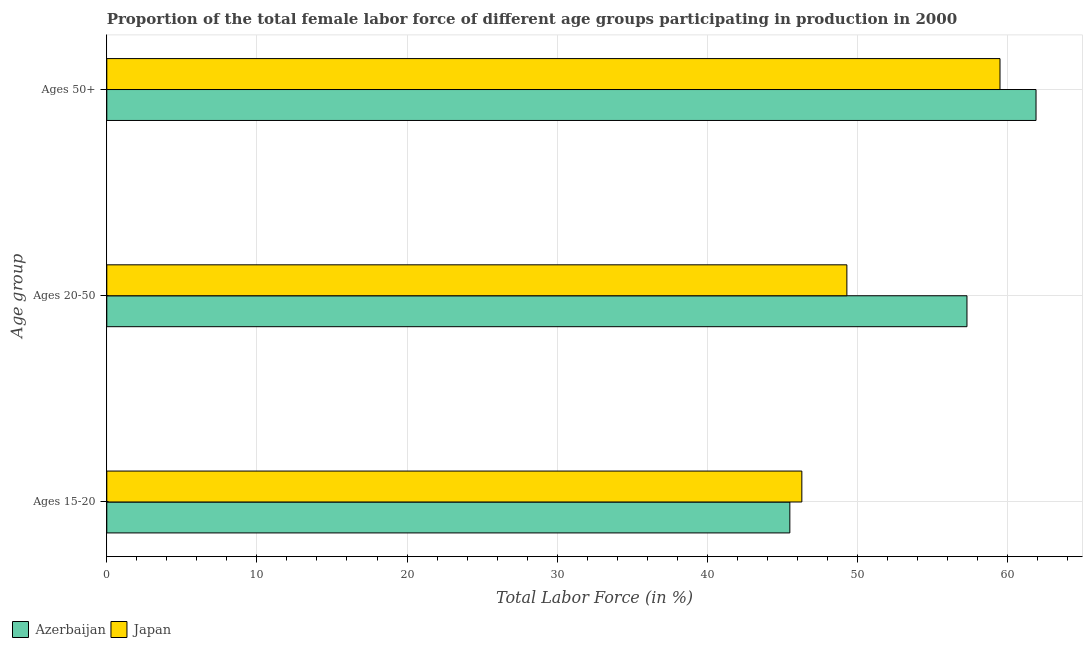Are the number of bars per tick equal to the number of legend labels?
Provide a short and direct response. Yes. Are the number of bars on each tick of the Y-axis equal?
Keep it short and to the point. Yes. How many bars are there on the 1st tick from the top?
Keep it short and to the point. 2. How many bars are there on the 3rd tick from the bottom?
Offer a terse response. 2. What is the label of the 3rd group of bars from the top?
Your answer should be very brief. Ages 15-20. What is the percentage of female labor force within the age group 15-20 in Japan?
Your answer should be very brief. 46.3. Across all countries, what is the maximum percentage of female labor force above age 50?
Provide a short and direct response. 61.9. Across all countries, what is the minimum percentage of female labor force within the age group 15-20?
Keep it short and to the point. 45.5. In which country was the percentage of female labor force within the age group 20-50 maximum?
Offer a terse response. Azerbaijan. In which country was the percentage of female labor force within the age group 15-20 minimum?
Provide a succinct answer. Azerbaijan. What is the total percentage of female labor force within the age group 20-50 in the graph?
Keep it short and to the point. 106.6. What is the difference between the percentage of female labor force above age 50 in Japan and that in Azerbaijan?
Your response must be concise. -2.4. What is the difference between the percentage of female labor force within the age group 20-50 in Azerbaijan and the percentage of female labor force within the age group 15-20 in Japan?
Make the answer very short. 11. What is the average percentage of female labor force above age 50 per country?
Provide a short and direct response. 60.7. What is the difference between the percentage of female labor force above age 50 and percentage of female labor force within the age group 15-20 in Azerbaijan?
Offer a terse response. 16.4. What is the ratio of the percentage of female labor force within the age group 20-50 in Japan to that in Azerbaijan?
Your answer should be compact. 0.86. Is the difference between the percentage of female labor force above age 50 in Azerbaijan and Japan greater than the difference between the percentage of female labor force within the age group 20-50 in Azerbaijan and Japan?
Your response must be concise. No. What is the difference between the highest and the second highest percentage of female labor force above age 50?
Make the answer very short. 2.4. What is the difference between the highest and the lowest percentage of female labor force above age 50?
Give a very brief answer. 2.4. In how many countries, is the percentage of female labor force above age 50 greater than the average percentage of female labor force above age 50 taken over all countries?
Keep it short and to the point. 1. Is the sum of the percentage of female labor force within the age group 20-50 in Japan and Azerbaijan greater than the maximum percentage of female labor force above age 50 across all countries?
Provide a short and direct response. Yes. What does the 1st bar from the bottom in Ages 15-20 represents?
Keep it short and to the point. Azerbaijan. How many bars are there?
Offer a very short reply. 6. Does the graph contain grids?
Ensure brevity in your answer.  Yes. How many legend labels are there?
Give a very brief answer. 2. What is the title of the graph?
Your answer should be compact. Proportion of the total female labor force of different age groups participating in production in 2000. Does "OECD members" appear as one of the legend labels in the graph?
Provide a short and direct response. No. What is the label or title of the X-axis?
Your response must be concise. Total Labor Force (in %). What is the label or title of the Y-axis?
Keep it short and to the point. Age group. What is the Total Labor Force (in %) in Azerbaijan in Ages 15-20?
Make the answer very short. 45.5. What is the Total Labor Force (in %) of Japan in Ages 15-20?
Offer a very short reply. 46.3. What is the Total Labor Force (in %) in Azerbaijan in Ages 20-50?
Keep it short and to the point. 57.3. What is the Total Labor Force (in %) in Japan in Ages 20-50?
Ensure brevity in your answer.  49.3. What is the Total Labor Force (in %) in Azerbaijan in Ages 50+?
Give a very brief answer. 61.9. What is the Total Labor Force (in %) in Japan in Ages 50+?
Your response must be concise. 59.5. Across all Age group, what is the maximum Total Labor Force (in %) of Azerbaijan?
Provide a succinct answer. 61.9. Across all Age group, what is the maximum Total Labor Force (in %) in Japan?
Ensure brevity in your answer.  59.5. Across all Age group, what is the minimum Total Labor Force (in %) in Azerbaijan?
Your answer should be compact. 45.5. Across all Age group, what is the minimum Total Labor Force (in %) in Japan?
Your answer should be very brief. 46.3. What is the total Total Labor Force (in %) in Azerbaijan in the graph?
Provide a succinct answer. 164.7. What is the total Total Labor Force (in %) of Japan in the graph?
Provide a short and direct response. 155.1. What is the difference between the Total Labor Force (in %) in Azerbaijan in Ages 15-20 and that in Ages 20-50?
Ensure brevity in your answer.  -11.8. What is the difference between the Total Labor Force (in %) in Azerbaijan in Ages 15-20 and that in Ages 50+?
Offer a terse response. -16.4. What is the difference between the Total Labor Force (in %) of Japan in Ages 20-50 and that in Ages 50+?
Keep it short and to the point. -10.2. What is the difference between the Total Labor Force (in %) of Azerbaijan in Ages 20-50 and the Total Labor Force (in %) of Japan in Ages 50+?
Provide a short and direct response. -2.2. What is the average Total Labor Force (in %) of Azerbaijan per Age group?
Offer a very short reply. 54.9. What is the average Total Labor Force (in %) of Japan per Age group?
Provide a short and direct response. 51.7. What is the ratio of the Total Labor Force (in %) in Azerbaijan in Ages 15-20 to that in Ages 20-50?
Offer a very short reply. 0.79. What is the ratio of the Total Labor Force (in %) in Japan in Ages 15-20 to that in Ages 20-50?
Keep it short and to the point. 0.94. What is the ratio of the Total Labor Force (in %) in Azerbaijan in Ages 15-20 to that in Ages 50+?
Your answer should be very brief. 0.74. What is the ratio of the Total Labor Force (in %) in Japan in Ages 15-20 to that in Ages 50+?
Your answer should be compact. 0.78. What is the ratio of the Total Labor Force (in %) in Azerbaijan in Ages 20-50 to that in Ages 50+?
Offer a terse response. 0.93. What is the ratio of the Total Labor Force (in %) in Japan in Ages 20-50 to that in Ages 50+?
Keep it short and to the point. 0.83. What is the difference between the highest and the second highest Total Labor Force (in %) of Azerbaijan?
Offer a very short reply. 4.6. What is the difference between the highest and the second highest Total Labor Force (in %) in Japan?
Give a very brief answer. 10.2. 